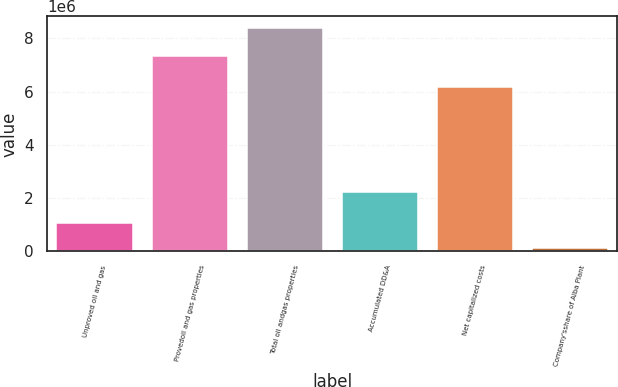Convert chart to OTSL. <chart><loc_0><loc_0><loc_500><loc_500><bar_chart><fcel>Unproved oil and gas<fcel>Provedoil and gas properties<fcel>Total oil andgas properties<fcel>Accumulated DD&A<fcel>Net capitalized costs<fcel>Company'sshare of Alba Plant<nl><fcel>1.06689e+06<fcel>7.33519e+06<fcel>8.40208e+06<fcel>2.2396e+06<fcel>6.16248e+06<fcel>134067<nl></chart> 